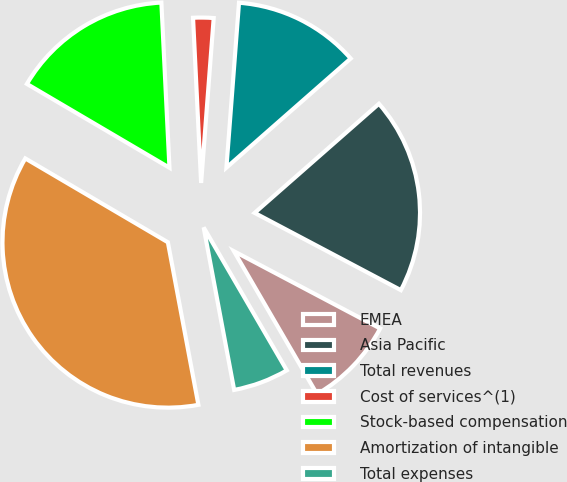Convert chart to OTSL. <chart><loc_0><loc_0><loc_500><loc_500><pie_chart><fcel>EMEA<fcel>Asia Pacific<fcel>Total revenues<fcel>Cost of services^(1)<fcel>Stock-based compensation<fcel>Amortization of intangible<fcel>Total expenses<nl><fcel>8.88%<fcel>19.2%<fcel>12.32%<fcel>1.99%<fcel>15.76%<fcel>36.41%<fcel>5.43%<nl></chart> 